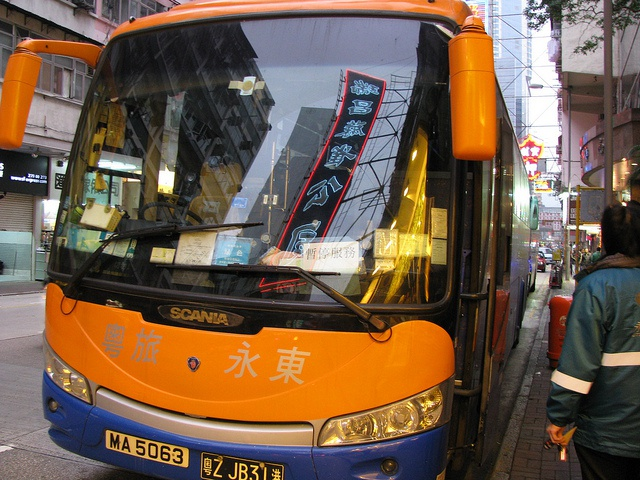Describe the objects in this image and their specific colors. I can see bus in black, orange, darkgray, and gray tones, people in black, blue, and gray tones, people in black, gray, tan, and darkgreen tones, people in black, teal, and darkgreen tones, and people in black, gray, darkgray, and white tones in this image. 